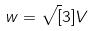<formula> <loc_0><loc_0><loc_500><loc_500>w = \sqrt { [ } 3 ] { V }</formula> 